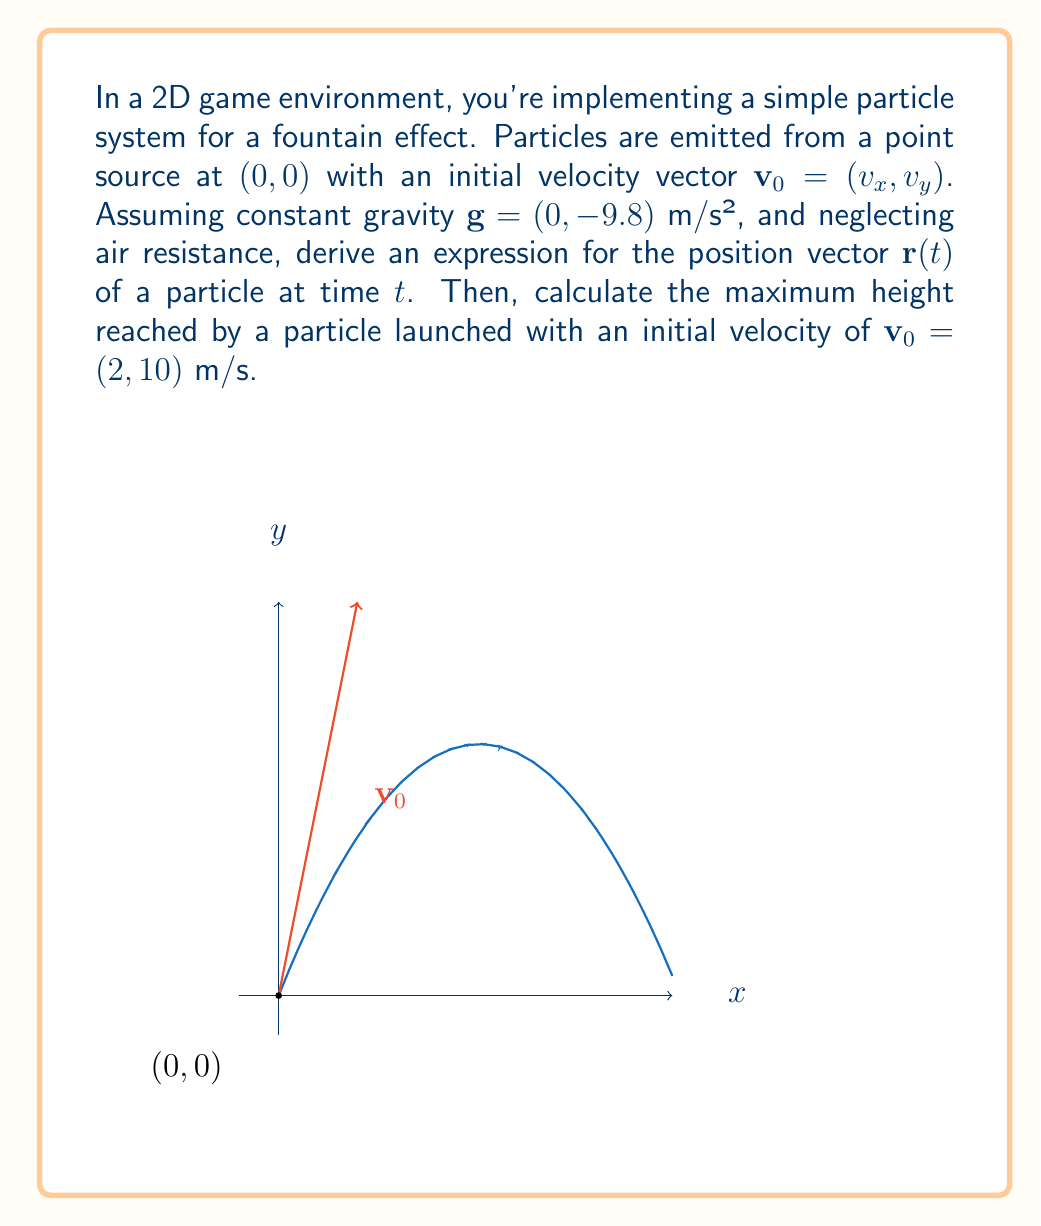What is the answer to this math problem? Let's approach this step-by-step:

1) The position vector $\mathbf{r}(t)$ is a function of time $t$. We can split it into x and y components:

   $\mathbf{r}(t) = (x(t), y(t))$

2) For the x-component, there's no acceleration (gravity only acts vertically). So:

   $x(t) = x_0 + v_x t$

   Where $x_0 = 0$ (starting at origin), so $x(t) = v_x t$

3) For the y-component, we have constant acceleration due to gravity:

   $y(t) = y_0 + v_y t + \frac{1}{2}g t^2$

   Where $y_0 = 0$, and $g = -9.8$ m/s²

4) Combining these, we get:

   $\mathbf{r}(t) = (v_x t, v_y t - 4.9t^2)$

5) To find the maximum height, we need to find when the y-velocity becomes zero:

   $v_y(t) = v_y - gt = 0$
   $t = \frac{v_y}{g} = \frac{10}{9.8} \approx 1.02$ seconds

6) Plugging this time back into our y(t) equation:

   $y_{max} = v_y (\frac{v_y}{g}) - 4.9(\frac{v_y}{g})^2$
             $= \frac{v_y^2}{g} - \frac{v_y^2}{2g}$
             $= \frac{v_y^2}{2g}$

7) With $v_y = 10$ m/s and $g = 9.8$ m/s²:

   $y_{max} = \frac{10^2}{2(9.8)} \approx 5.10$ meters
Answer: $\mathbf{r}(t) = (v_x t, v_y t - 4.9t^2)$; Maximum height: 5.10 m 